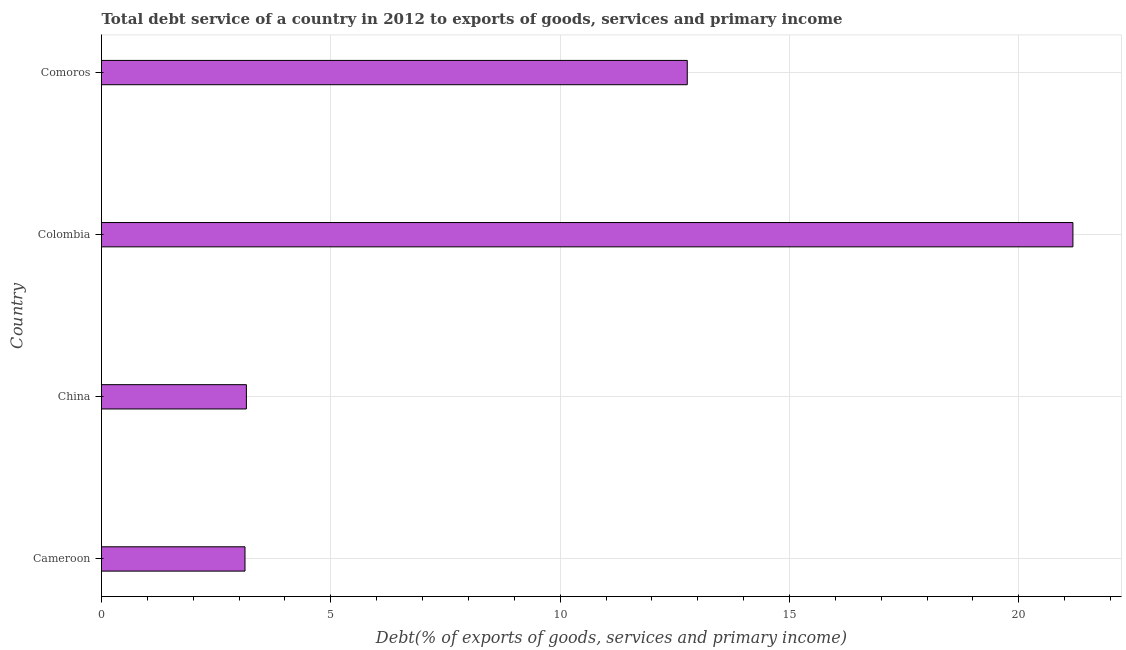Does the graph contain grids?
Provide a succinct answer. Yes. What is the title of the graph?
Make the answer very short. Total debt service of a country in 2012 to exports of goods, services and primary income. What is the label or title of the X-axis?
Your response must be concise. Debt(% of exports of goods, services and primary income). What is the label or title of the Y-axis?
Offer a terse response. Country. What is the total debt service in Comoros?
Keep it short and to the point. 12.77. Across all countries, what is the maximum total debt service?
Your answer should be compact. 21.18. Across all countries, what is the minimum total debt service?
Provide a short and direct response. 3.13. In which country was the total debt service maximum?
Your answer should be very brief. Colombia. In which country was the total debt service minimum?
Your response must be concise. Cameroon. What is the sum of the total debt service?
Ensure brevity in your answer.  40.24. What is the difference between the total debt service in China and Comoros?
Provide a short and direct response. -9.61. What is the average total debt service per country?
Your response must be concise. 10.06. What is the median total debt service?
Ensure brevity in your answer.  7.96. In how many countries, is the total debt service greater than 11 %?
Your response must be concise. 2. What is the ratio of the total debt service in Cameroon to that in Comoros?
Offer a terse response. 0.24. Is the difference between the total debt service in Cameroon and China greater than the difference between any two countries?
Your response must be concise. No. What is the difference between the highest and the second highest total debt service?
Make the answer very short. 8.41. Is the sum of the total debt service in Cameroon and China greater than the maximum total debt service across all countries?
Your answer should be very brief. No. What is the difference between the highest and the lowest total debt service?
Your answer should be very brief. 18.05. In how many countries, is the total debt service greater than the average total debt service taken over all countries?
Ensure brevity in your answer.  2. What is the difference between two consecutive major ticks on the X-axis?
Your answer should be very brief. 5. What is the Debt(% of exports of goods, services and primary income) in Cameroon?
Offer a terse response. 3.13. What is the Debt(% of exports of goods, services and primary income) in China?
Offer a terse response. 3.16. What is the Debt(% of exports of goods, services and primary income) in Colombia?
Make the answer very short. 21.18. What is the Debt(% of exports of goods, services and primary income) of Comoros?
Provide a succinct answer. 12.77. What is the difference between the Debt(% of exports of goods, services and primary income) in Cameroon and China?
Ensure brevity in your answer.  -0.03. What is the difference between the Debt(% of exports of goods, services and primary income) in Cameroon and Colombia?
Offer a terse response. -18.05. What is the difference between the Debt(% of exports of goods, services and primary income) in Cameroon and Comoros?
Provide a short and direct response. -9.64. What is the difference between the Debt(% of exports of goods, services and primary income) in China and Colombia?
Offer a very short reply. -18.02. What is the difference between the Debt(% of exports of goods, services and primary income) in China and Comoros?
Ensure brevity in your answer.  -9.61. What is the difference between the Debt(% of exports of goods, services and primary income) in Colombia and Comoros?
Offer a very short reply. 8.41. What is the ratio of the Debt(% of exports of goods, services and primary income) in Cameroon to that in China?
Make the answer very short. 0.99. What is the ratio of the Debt(% of exports of goods, services and primary income) in Cameroon to that in Colombia?
Give a very brief answer. 0.15. What is the ratio of the Debt(% of exports of goods, services and primary income) in Cameroon to that in Comoros?
Ensure brevity in your answer.  0.24. What is the ratio of the Debt(% of exports of goods, services and primary income) in China to that in Colombia?
Ensure brevity in your answer.  0.15. What is the ratio of the Debt(% of exports of goods, services and primary income) in China to that in Comoros?
Offer a very short reply. 0.25. What is the ratio of the Debt(% of exports of goods, services and primary income) in Colombia to that in Comoros?
Your response must be concise. 1.66. 